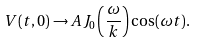Convert formula to latex. <formula><loc_0><loc_0><loc_500><loc_500>V ( t , 0 ) \rightarrow A J _ { 0 } \left ( \frac { \omega } { k } \right ) \cos ( \omega t ) .</formula> 